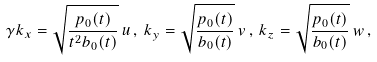Convert formula to latex. <formula><loc_0><loc_0><loc_500><loc_500>\gamma k _ { x } = \sqrt { \frac { p _ { 0 } ( t ) } { t ^ { 2 } b _ { 0 } ( t ) } } \, u \, , \, k _ { y } = \sqrt { \frac { p _ { 0 } ( t ) } { b _ { 0 } ( t ) } } \, v \, , \, k _ { z } = \sqrt { \frac { p _ { 0 } ( t ) } { b _ { 0 } ( t ) } } \, w \, ,</formula> 